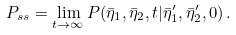<formula> <loc_0><loc_0><loc_500><loc_500>P _ { s s } = \lim _ { t \rightarrow \infty } P ( \bar { \eta } _ { 1 } , \bar { \eta } _ { 2 } , t | \bar { \eta } _ { 1 } ^ { \prime } , \bar { \eta } _ { 2 } ^ { \prime } , 0 ) \, .</formula> 